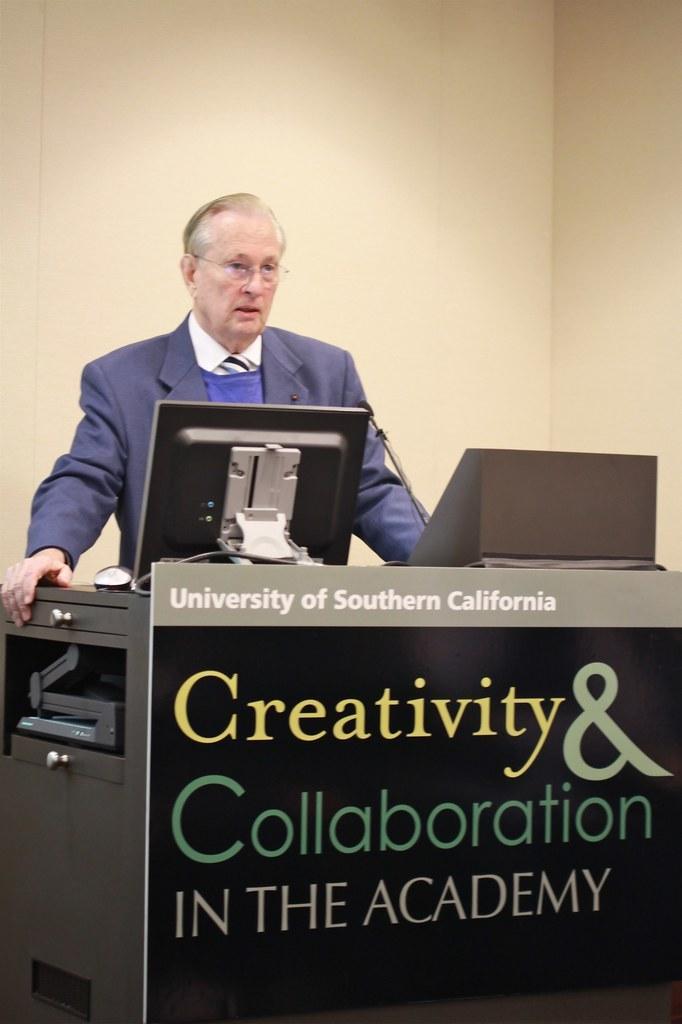Please provide a concise description of this image. In the image there is a man standing in front of a table, on the table there is a monitor, mouse and a mic. There is a board with some university name attached to the table. In the background there is a wall. 